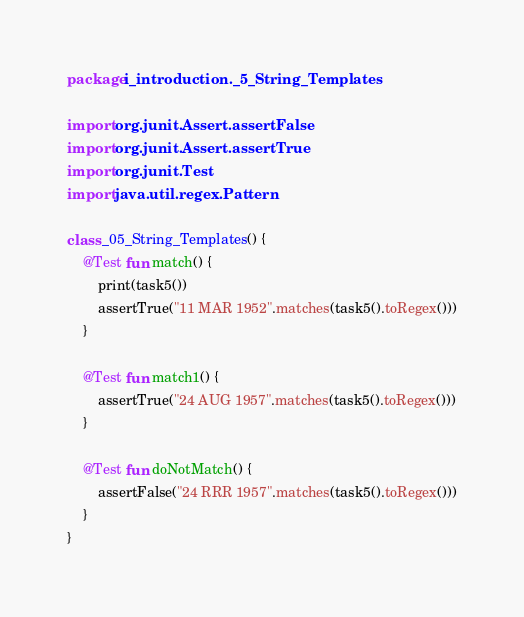Convert code to text. <code><loc_0><loc_0><loc_500><loc_500><_Kotlin_>package i_introduction._5_String_Templates

import org.junit.Assert.assertFalse
import org.junit.Assert.assertTrue
import org.junit.Test
import java.util.regex.Pattern

class _05_String_Templates() {
    @Test fun match() {
        print(task5())
        assertTrue("11 MAR 1952".matches(task5().toRegex()))
    }

    @Test fun match1() {
        assertTrue("24 AUG 1957".matches(task5().toRegex()))
    }

    @Test fun doNotMatch() {
        assertFalse("24 RRR 1957".matches(task5().toRegex()))
    }
}
</code> 